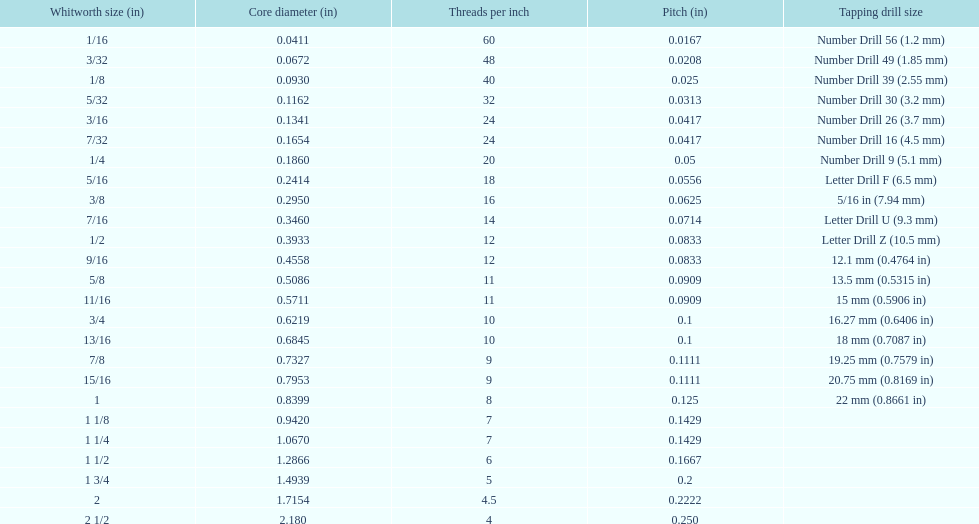What is the number of threads per inch in a 9/16? 12. 